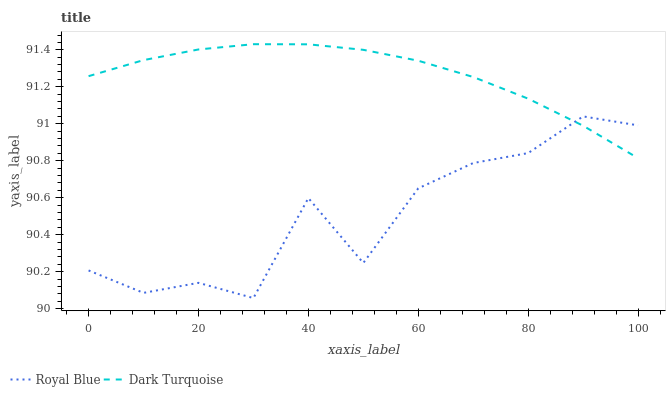Does Dark Turquoise have the minimum area under the curve?
Answer yes or no. No. Is Dark Turquoise the roughest?
Answer yes or no. No. Does Dark Turquoise have the lowest value?
Answer yes or no. No. 